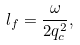<formula> <loc_0><loc_0><loc_500><loc_500>l _ { f } = \frac { \omega } { 2 q _ { c } ^ { 2 } } ,</formula> 